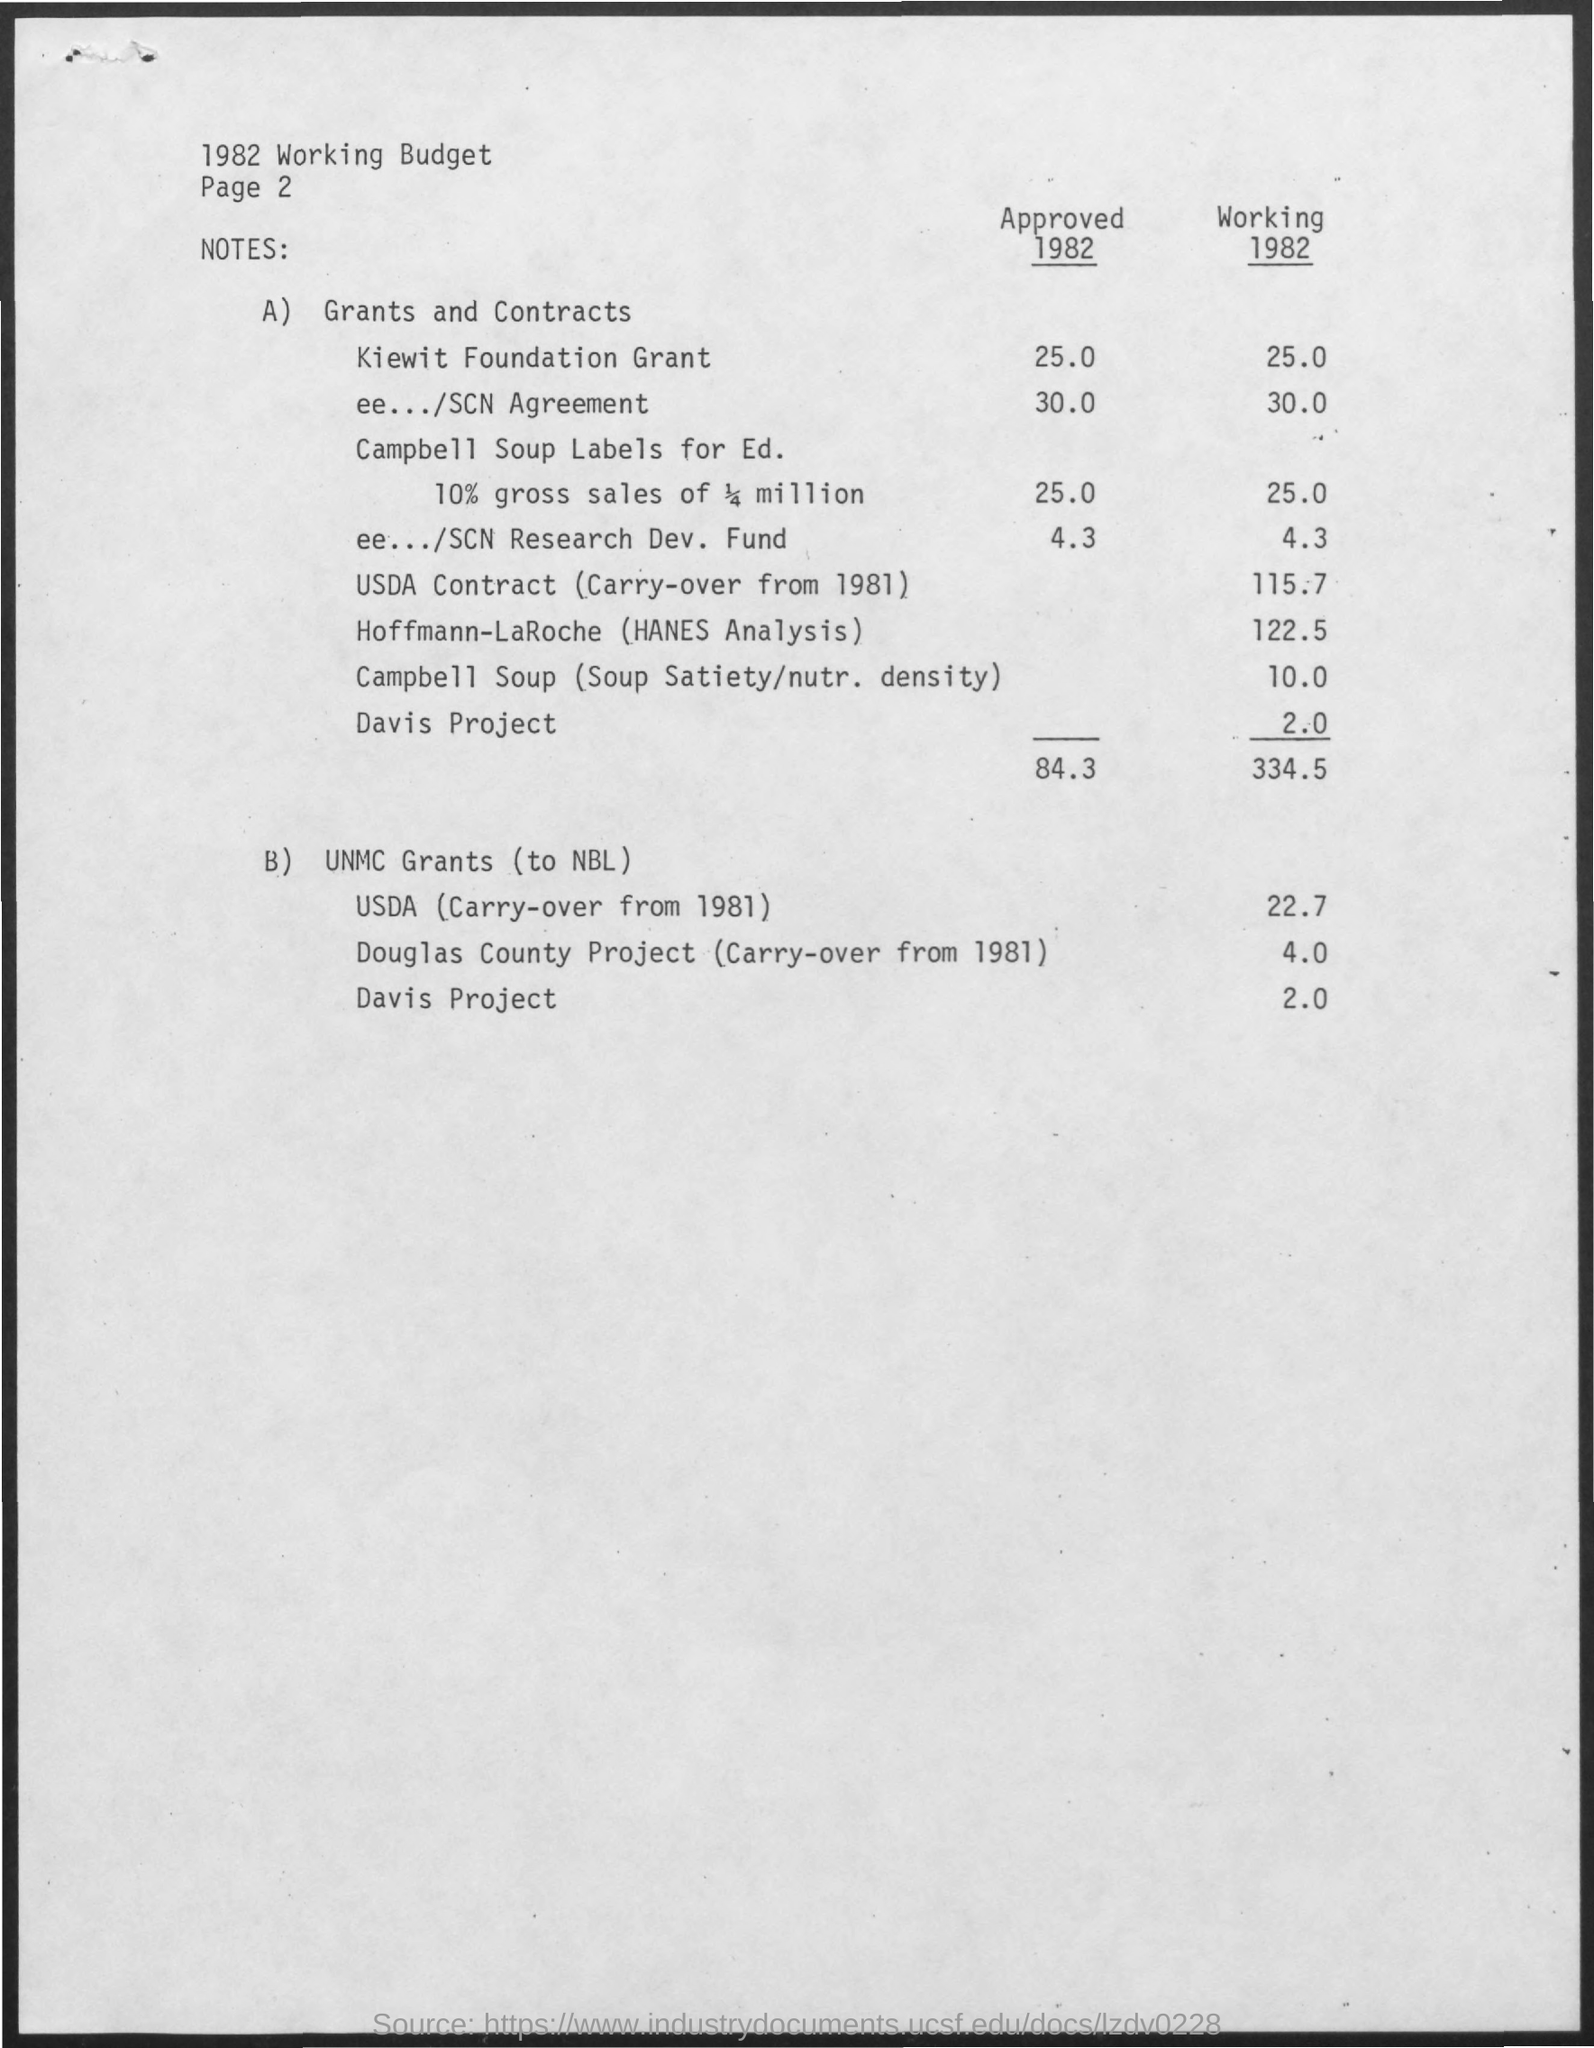Point out several critical features in this image. The title of the document is the 1982 working budget. The Working Budget for the USDA Contract in 1982 was $115.7 million, which represented a carryover from the previous year. The total approved budget for 1982 was $84.3 million. The working budget for the ee.../SCN Agreement for the year 1982 is $30,000. The total working budget in 1982 was 334.5. 